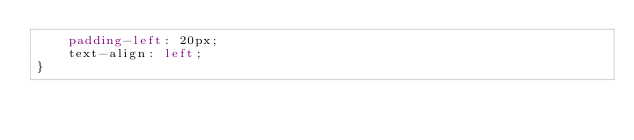<code> <loc_0><loc_0><loc_500><loc_500><_CSS_>    padding-left: 20px;
    text-align: left;        
}
</code> 